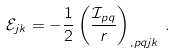Convert formula to latex. <formula><loc_0><loc_0><loc_500><loc_500>\mathcal { E } _ { j k } = - \frac { 1 } { 2 } \left ( \frac { \mathcal { I } _ { p q } } { r } \right ) _ { , p q j k } \, .</formula> 